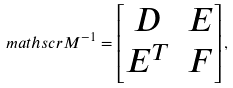Convert formula to latex. <formula><loc_0><loc_0><loc_500><loc_500>\ m a t h s c r { M } ^ { - 1 } = \begin{bmatrix} D & E \\ E ^ { T } & F \end{bmatrix} ,</formula> 